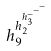Convert formula to latex. <formula><loc_0><loc_0><loc_500><loc_500>h _ { 9 } ^ { h _ { 2 } ^ { h _ { 3 } ^ { - ^ { - ^ { - } } } } }</formula> 